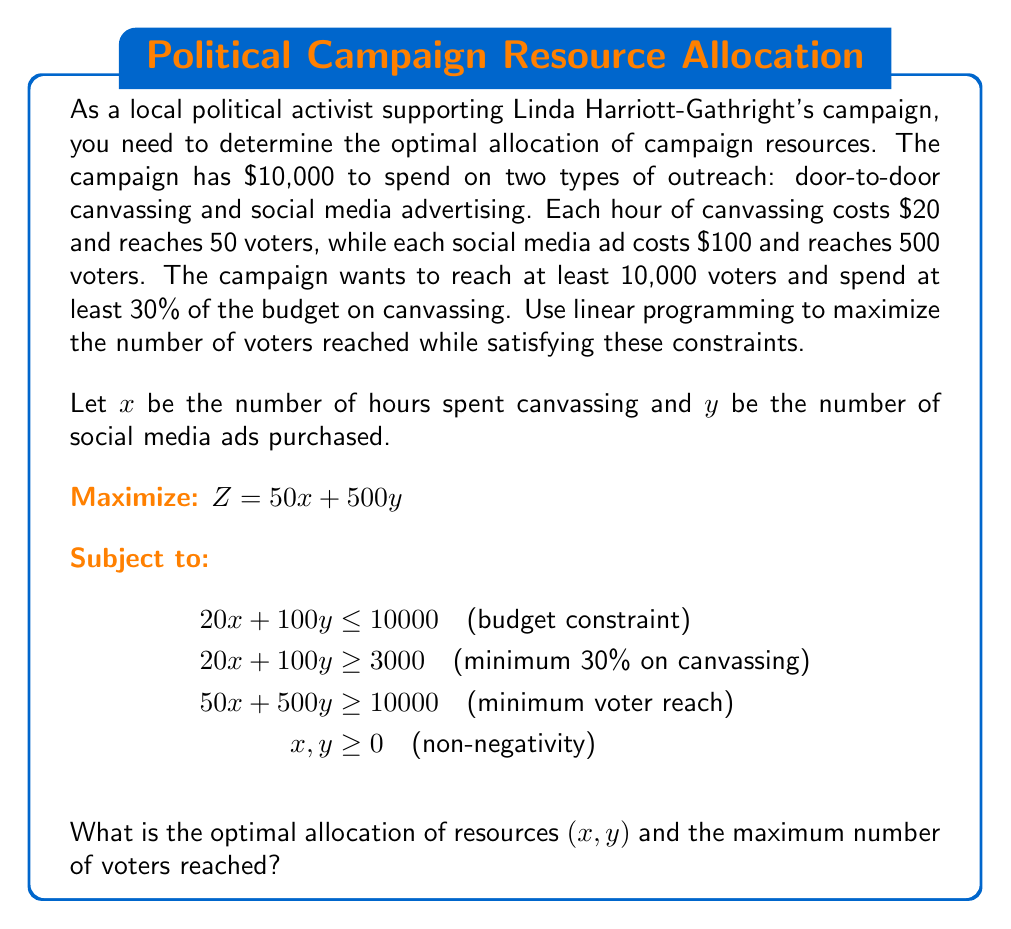Could you help me with this problem? To solve this linear programming problem, we'll use the graphical method:

1. Plot the constraints:
   - Budget: $20x + 100y = 10000$ or $y = 100 - 0.2x$
   - Minimum canvassing: $20x + 100y = 3000$ or $y = 30 - 0.2x$
   - Minimum voter reach: $50x + 500y = 10000$ or $y = 20 - 0.1x$

2. Identify the feasible region:
   The feasible region is bounded by these constraints and the non-negativity constraints.

3. Find the corner points of the feasible region:
   A: $(0, 100)$ - intersection of budget and y-axis
   B: $(150, 70)$ - intersection of budget and minimum voter reach
   C: $(200, 0)$ - intersection of minimum canvassing and x-axis

4. Evaluate the objective function at each corner point:
   A: $Z = 50(0) + 500(100) = 50,000$
   B: $Z = 50(150) + 500(70) = 42,500$
   C: $Z = 50(200) + 500(0) = 10,000$

5. The maximum value occurs at point A $(0, 100)$, which represents 0 hours of canvassing and 100 social media ads.

6. The maximum number of voters reached is 50,000.

[asy]
unitsize(2cm);
draw((0,0)--(5,0), arrow=Arrow(TeXHead));
draw((0,0)--(0,5), arrow=Arrow(TeXHead));
draw((0,1)--(5,0), blue);
draw((0,0.3)--(5,0), red);
draw((0,0.2)--(5,0), green);
label("x", (5,0), E);
label("y", (0,5), N);
label("Budget", (4,0.2), NE);
label("Min. canvassing", (4,0.5), NE);
label("Min. voter reach", (4,0.6), NE);
dot((0,1));
dot((1.5,0.7));
dot((2,0));
label("A", (0,1), NW);
label("B", (1.5,0.7), NE);
label("C", (2,0), SE);
fill((0,0.3)--(0,1)--(1.5,0.7)--(2,0)--cycle, opacity(0.2));
[/asy]
Answer: $(0, 100)$; 50,000 voters 